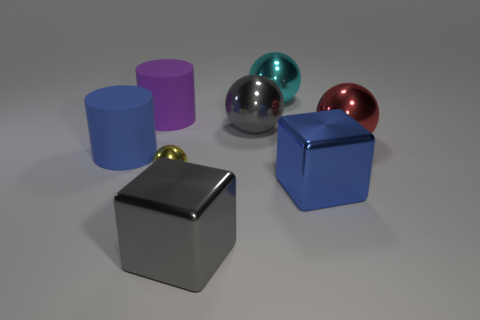Add 1 large cyan shiny things. How many objects exist? 9 Subtract all purple balls. Subtract all red cylinders. How many balls are left? 4 Subtract all cubes. How many objects are left? 6 Add 7 yellow shiny objects. How many yellow shiny objects are left? 8 Add 6 red metal spheres. How many red metal spheres exist? 7 Subtract 1 gray cubes. How many objects are left? 7 Subtract all big brown metallic cylinders. Subtract all gray blocks. How many objects are left? 7 